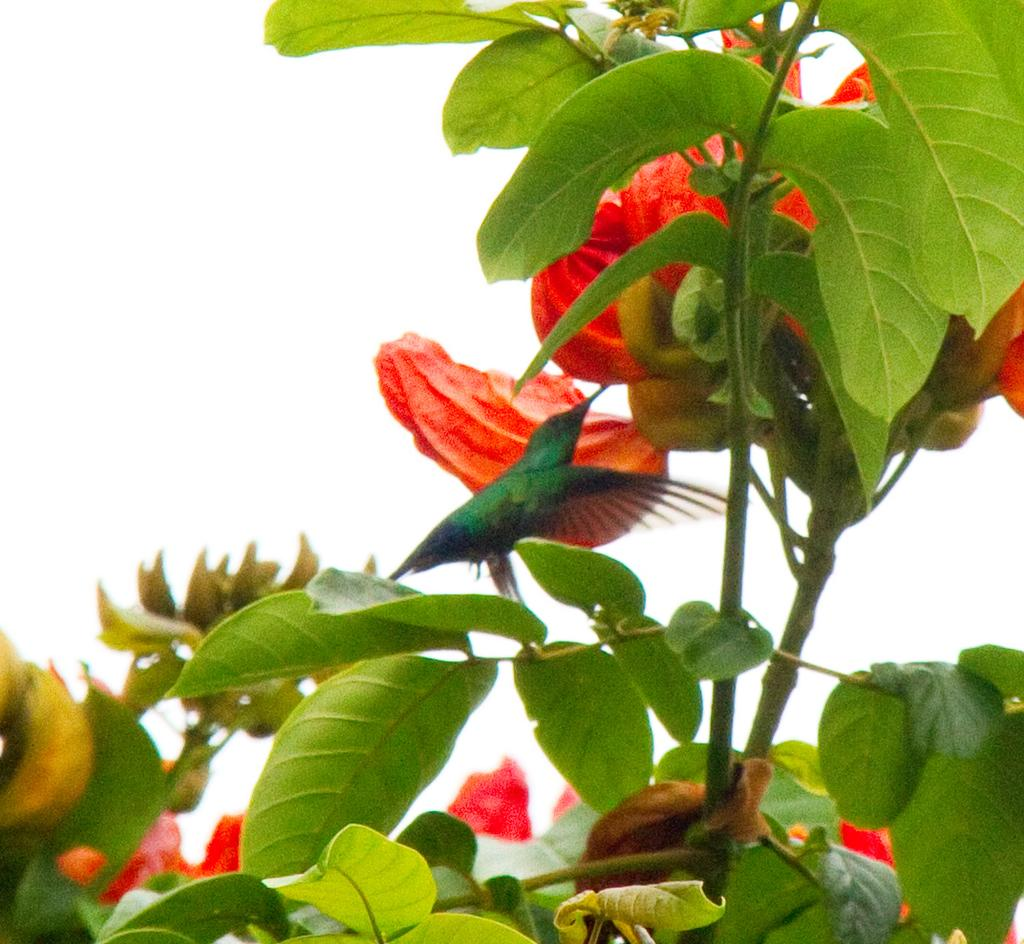What is present in the image? There is a tree in the image. Is there anything on the tree? Yes, there is a bird on the tree. What type of creature is coiled around the tree in the image? There is no creature coiled around the tree in the image; only a bird is present on the tree. What scent can be detected from the tree in the image? The image does not provide information about the scent of the tree, so it cannot be determined from the image. 